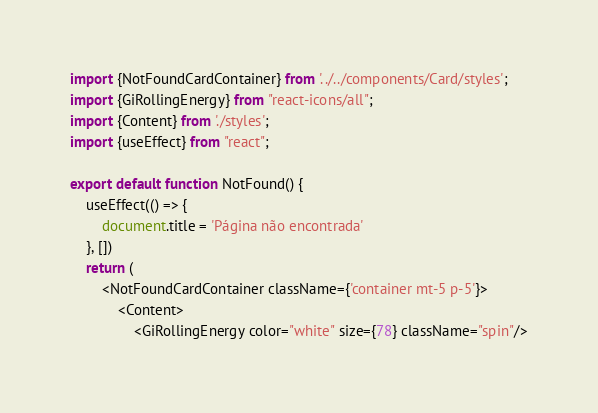<code> <loc_0><loc_0><loc_500><loc_500><_TypeScript_>import {NotFoundCardContainer} from '../../components/Card/styles';
import {GiRollingEnergy} from "react-icons/all";
import {Content} from './styles';
import {useEffect} from "react";

export default function NotFound() {
    useEffect(() => {
        document.title = 'Página não encontrada'
    }, [])
    return (
        <NotFoundCardContainer className={'container mt-5 p-5'}>
            <Content>
                <GiRollingEnergy color="white" size={78} className="spin"/></code> 